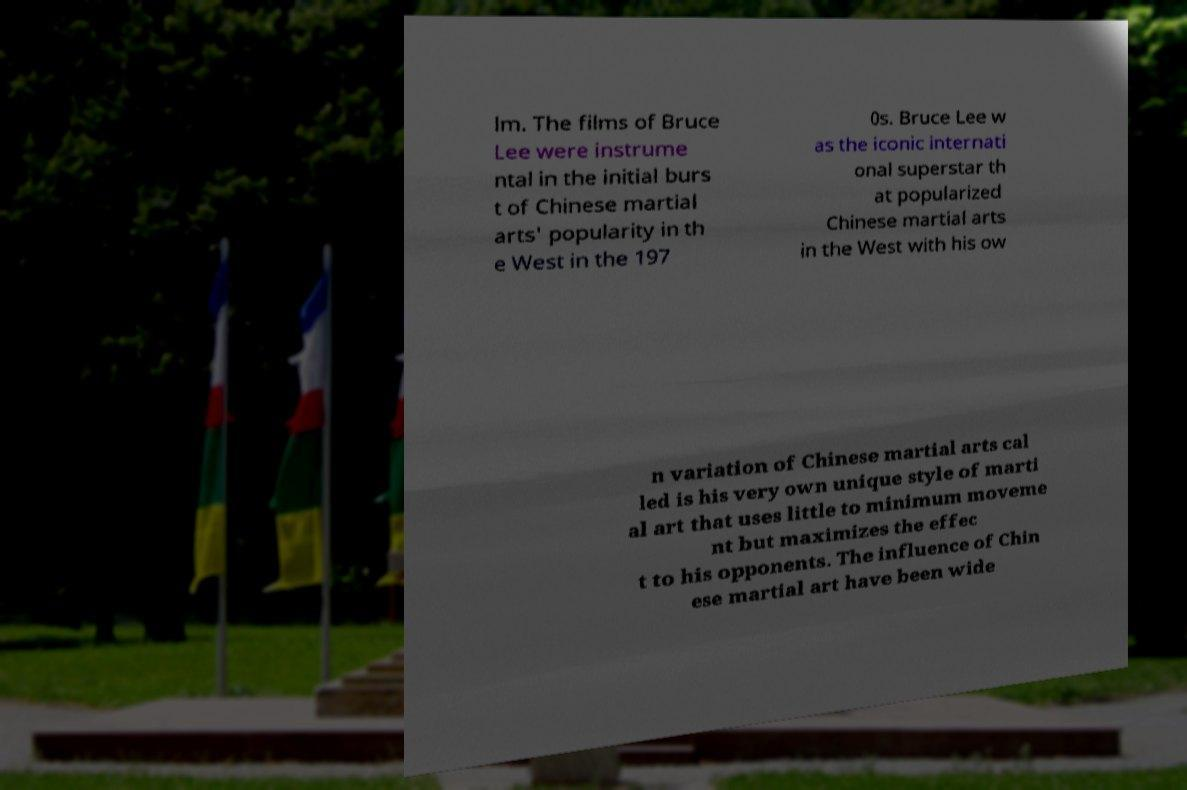Please identify and transcribe the text found in this image. lm. The films of Bruce Lee were instrume ntal in the initial burs t of Chinese martial arts' popularity in th e West in the 197 0s. Bruce Lee w as the iconic internati onal superstar th at popularized Chinese martial arts in the West with his ow n variation of Chinese martial arts cal led is his very own unique style of marti al art that uses little to minimum moveme nt but maximizes the effec t to his opponents. The influence of Chin ese martial art have been wide 